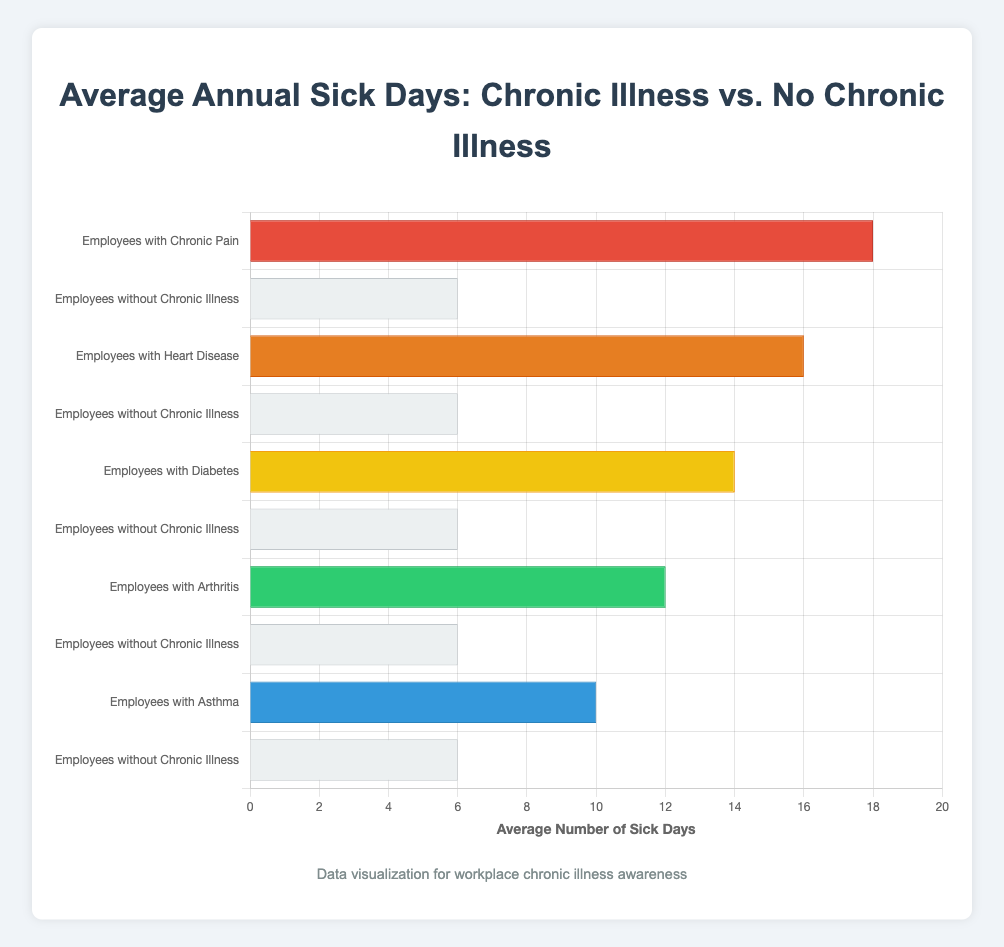What is the average number of sick days taken annually by employees with diabetes? To find this, look at the bar labeled "Employees with Diabetes" and note its length/value.
Answer: 14 How many more sick days do employees with heart disease take compared to employees without chronic illness annually? Locate the bars for "Employees with Heart Disease" and "Employees without Chronic Illness". Subtract the latter's value (6) from the former's value (16).
Answer: 10 Which group of employees takes the most sick days annually? Identify the bar with the greatest length, referring to the corresponding group.
Answer: Employees with Chronic Pain How many sick days do employees with chronic pain take relative to those with asthma annually? Find the bars for "Employees with Chronic Pain" and "Employees with Asthma". Note their values (18 for Chronic Pain and 10 for Asthma). Subtract to find the difference.
Answer: 8 What is the total number of sick days taken annually by employees without chronic illness? This group is represented multiple times; sum the values for "Employees without Chronic Illness" (6 + 6 + 6 + 6 + 6).
Answer: 30 By how much does the average number of sick days taken by employees with arthritis exceed those taken by employees without chronic illness? Compare the values for "Employees with Arthritis" (12) and "Employees without Chronic Illness" (6). Subtract the latter from the former.
Answer: 6 How does the average number of sick days taken by employees with diabetes compare to those with arthritis? Find the values for "Employees with Diabetes" (14) and "Employees with Arthritis" (12). Compare them directly.
Answer: Diabetes is higher by 2 Which has a higher average number of sick days: employees with asthma or employees with arthritis? Identify the values for "Employees with Asthma" (10) and "Employees with Arthritis" (12). Compare them to see which is larger.
Answer: Employees with Arthritis What is the visual indication that employees with chronic pain take the most sick days annually? The visual indication is the length of the bar for "Employees with Chronic Pain," which is the longest.
Answer: Longest Bar What is the average number of sick days taken annually by employees without chronic illness? Average is the same for all without chronic illness, look at any one of these values (6).
Answer: 6 